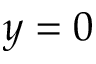<formula> <loc_0><loc_0><loc_500><loc_500>y = 0</formula> 